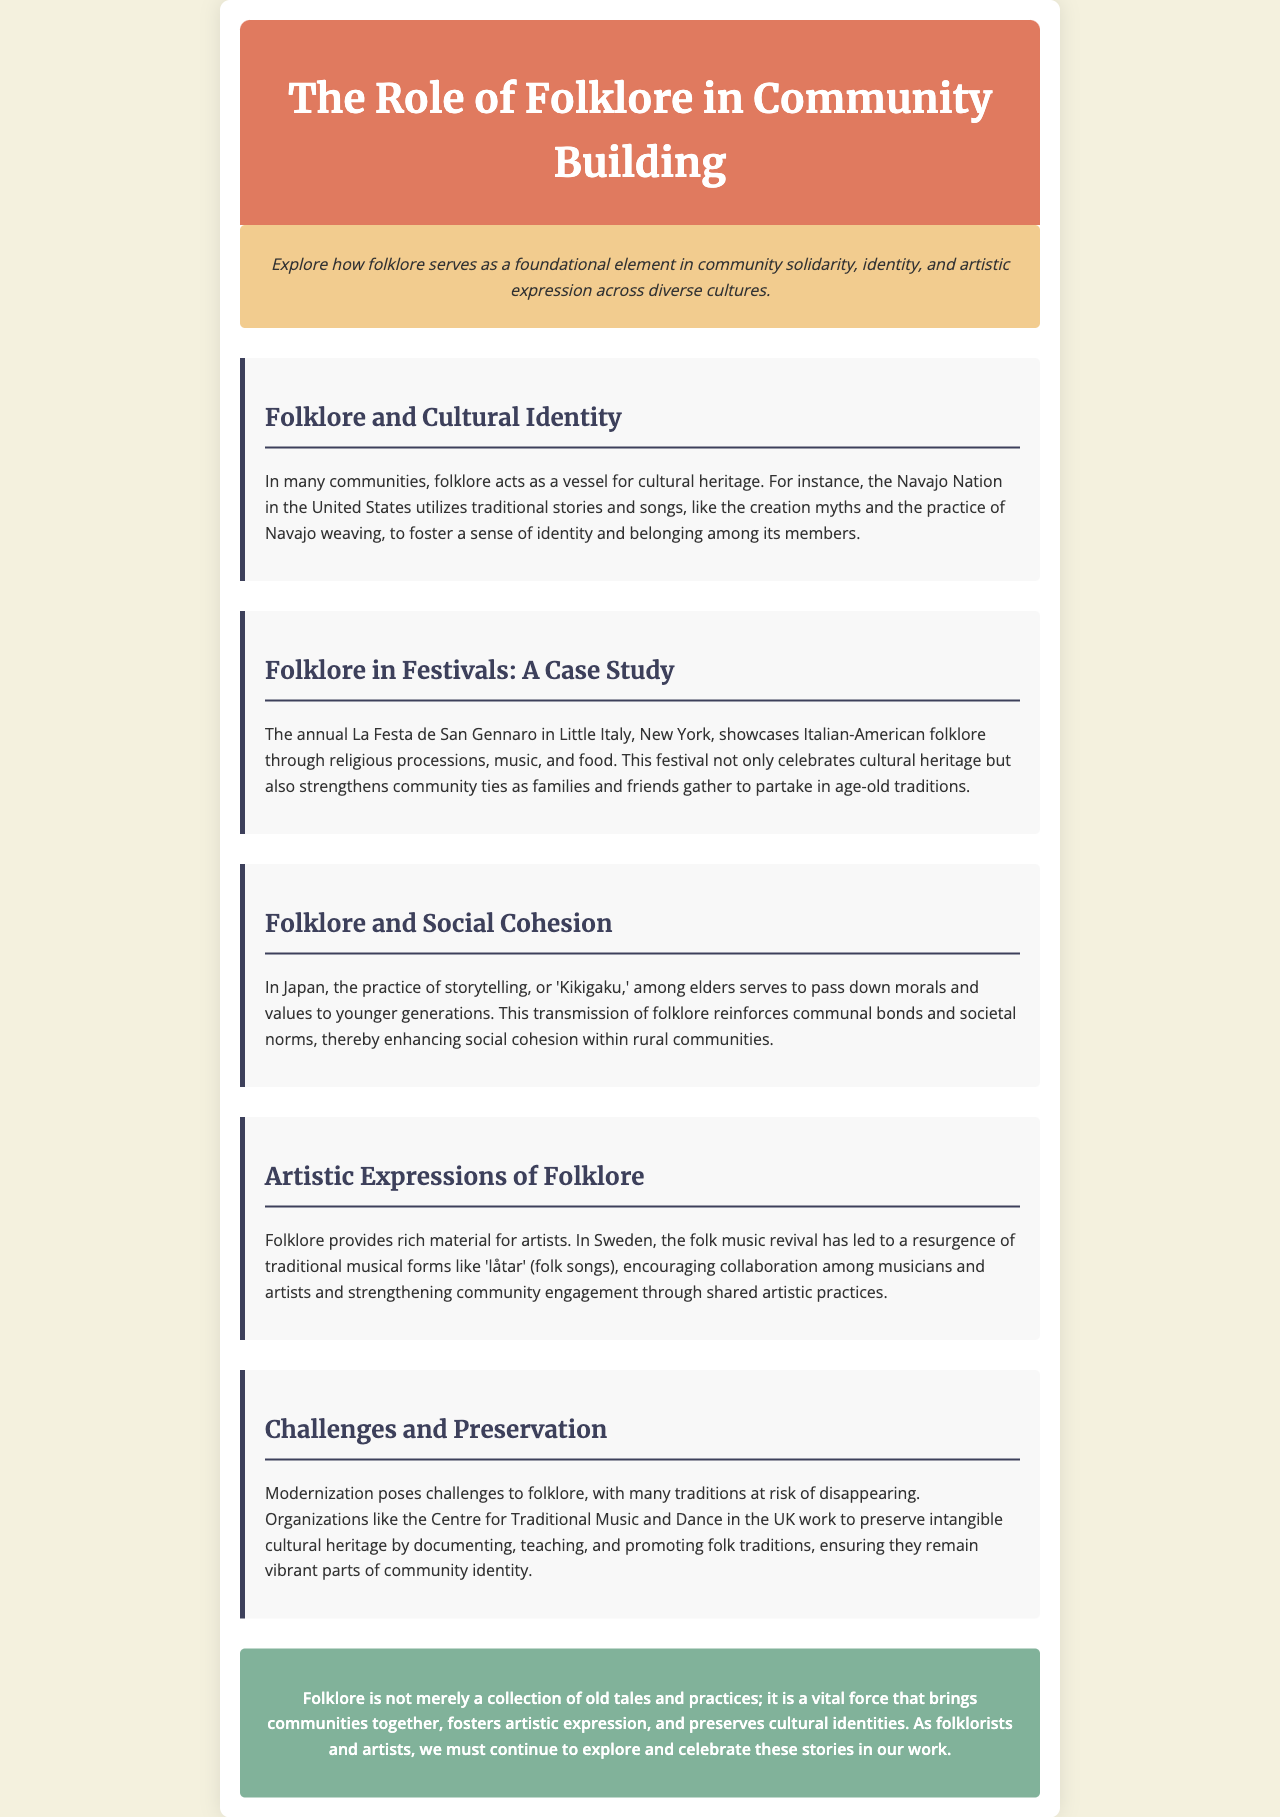What is the primary theme of the newsletter? The newsletter explores folklore's role in community building, specifically its contribution to solidarity, identity, and artistic expression.
Answer: Community building Which community uses traditional stories to foster identity? The document mentions the Navajo Nation in the United States as a community that utilizes traditional stories for fostering identity.
Answer: Navajo Nation What annual festival is highlighted for showcasing Italian-American folklore? The newsletter discusses the La Festa de San Gennaro in Little Italy, New York, as a significant festival for this purpose.
Answer: La Festa de San Gennaro What practice reinforces social cohesion in Japanese communities? "Kikigaku," the practice of storytelling among elders, reinforces social cohesion and transmits morals and values.
Answer: Kikigaku Which organization works to preserve intangible cultural heritage in the UK? The document mentions the Centre for Traditional Music and Dance as an organization working towards preservation efforts.
Answer: Centre for Traditional Music and Dance What traditional musical form has seen a revival in Sweden? The document refers to 'låtar' (folk songs) as a traditional musical form that has experienced a resurgence in Sweden.
Answer: låtar How does folklore serve artists according to the document? Folklore provides rich material for artists, leading to collaboration and enhanced community engagement through shared artistic practices.
Answer: Rich material What is a key challenge to folklore mentioned in the newsletter? The document states that modernization poses a significant challenge to the preservation of many traditions and folklore.
Answer: Modernization 